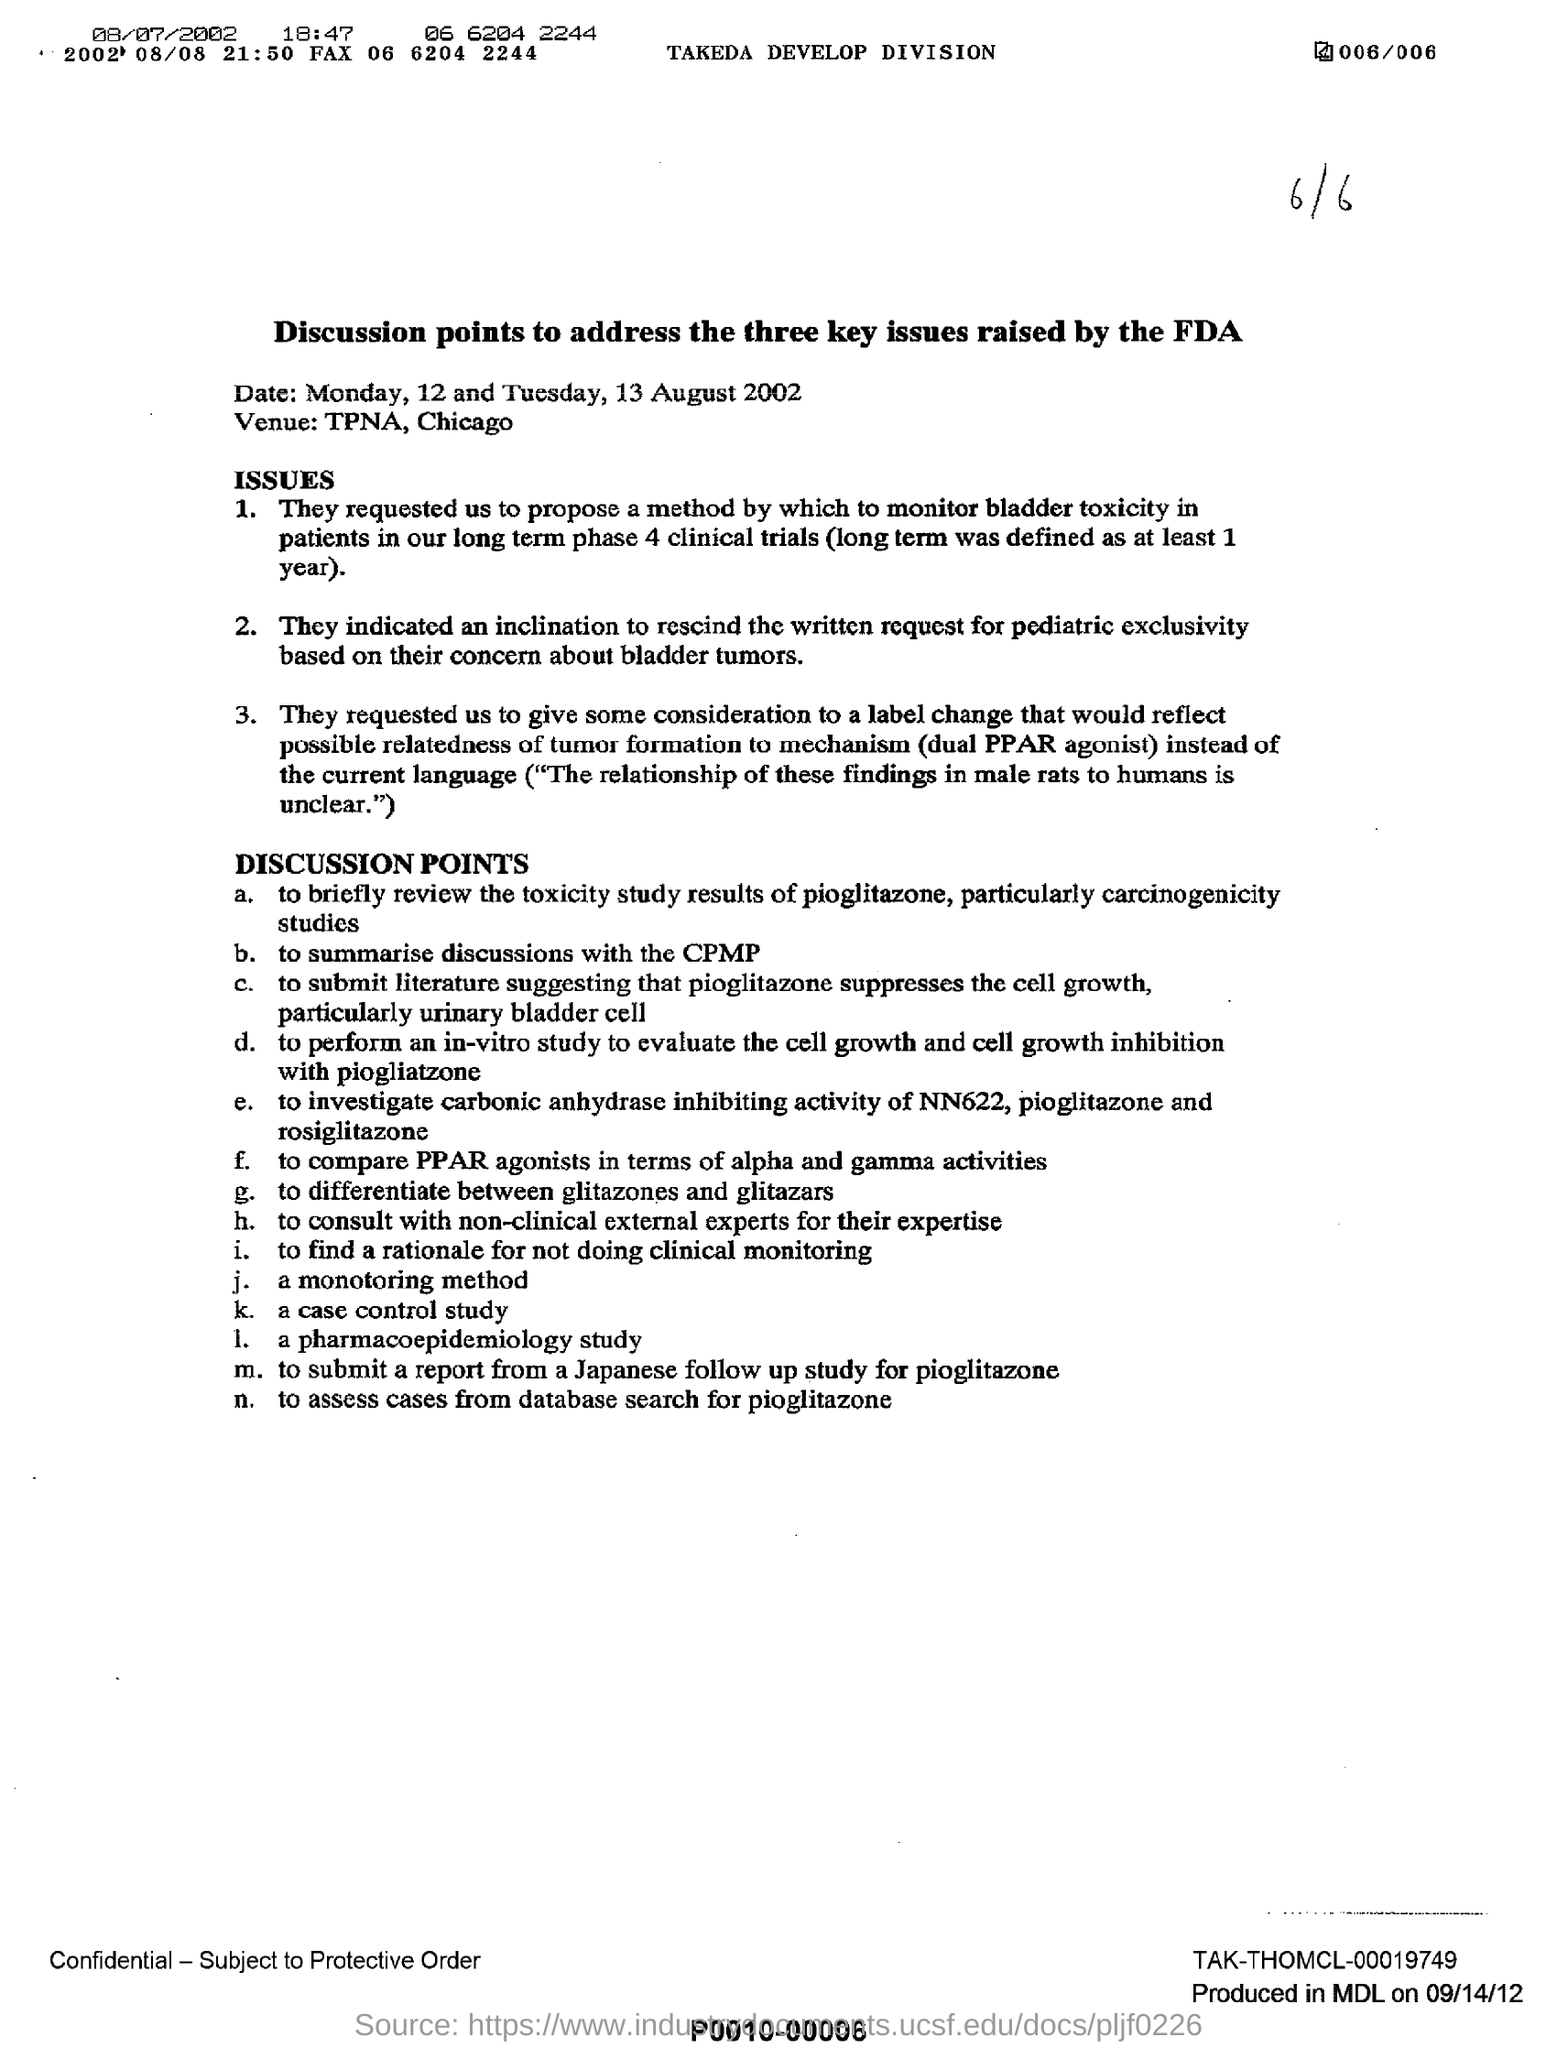What is the venue mentioned in the document?
Your answer should be very brief. TPNA, Chicago. What is the date mentioned in the document?
Offer a terse response. Monday, 12 and Tuesday, 13 August 2002. What is the fax number  mentioned in the letter at the top?
Provide a succinct answer. 06 6204 2244. Which drug's toxicity study results will be discussed ?
Make the answer very short. Pioglitazone. 